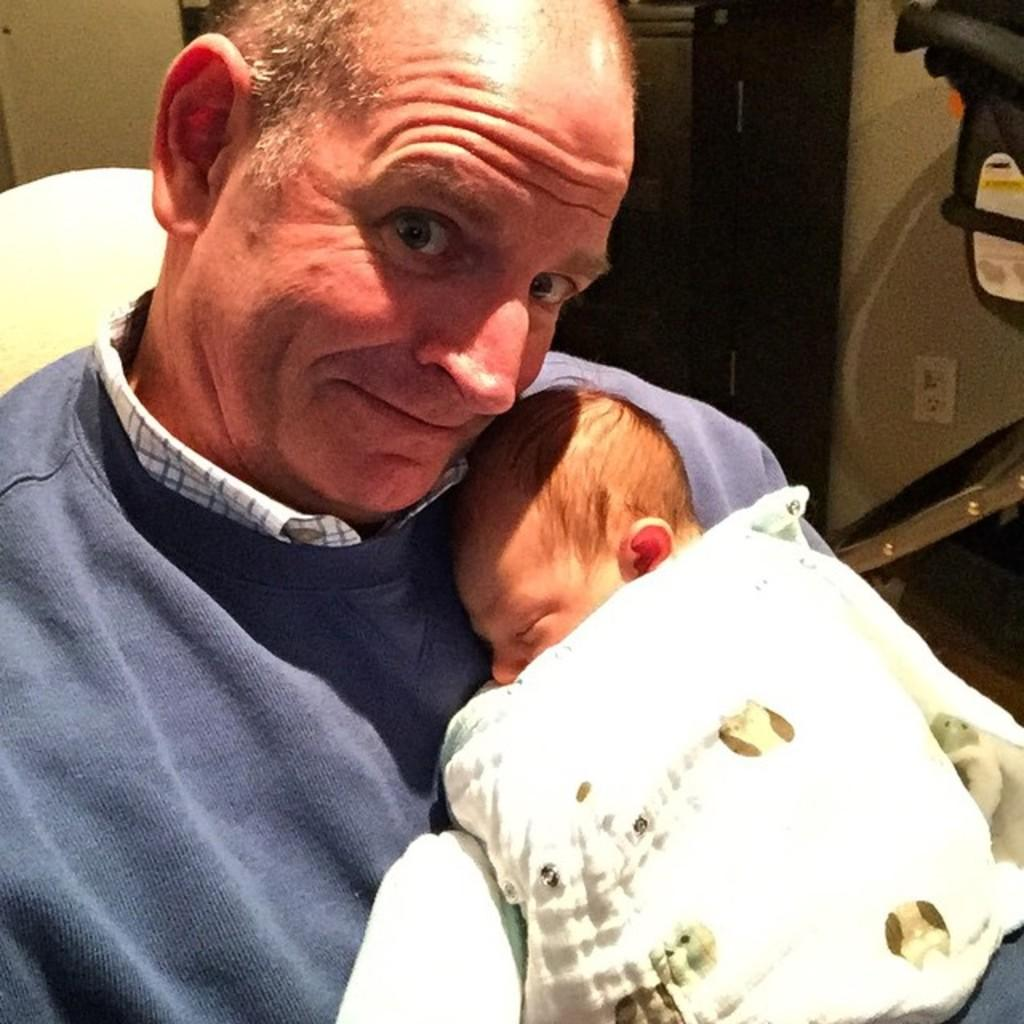What is the person in the image doing? The person is holding a baby in the image. What can be seen in the background of the image? There is a wall in the background of the image. Where is the picture of the hydrant located in the image? There is no picture of a hydrant present in the image. What type of linen is draped over the baby in the image? There is no linen visible in the image; the baby is not covered by any fabric. 